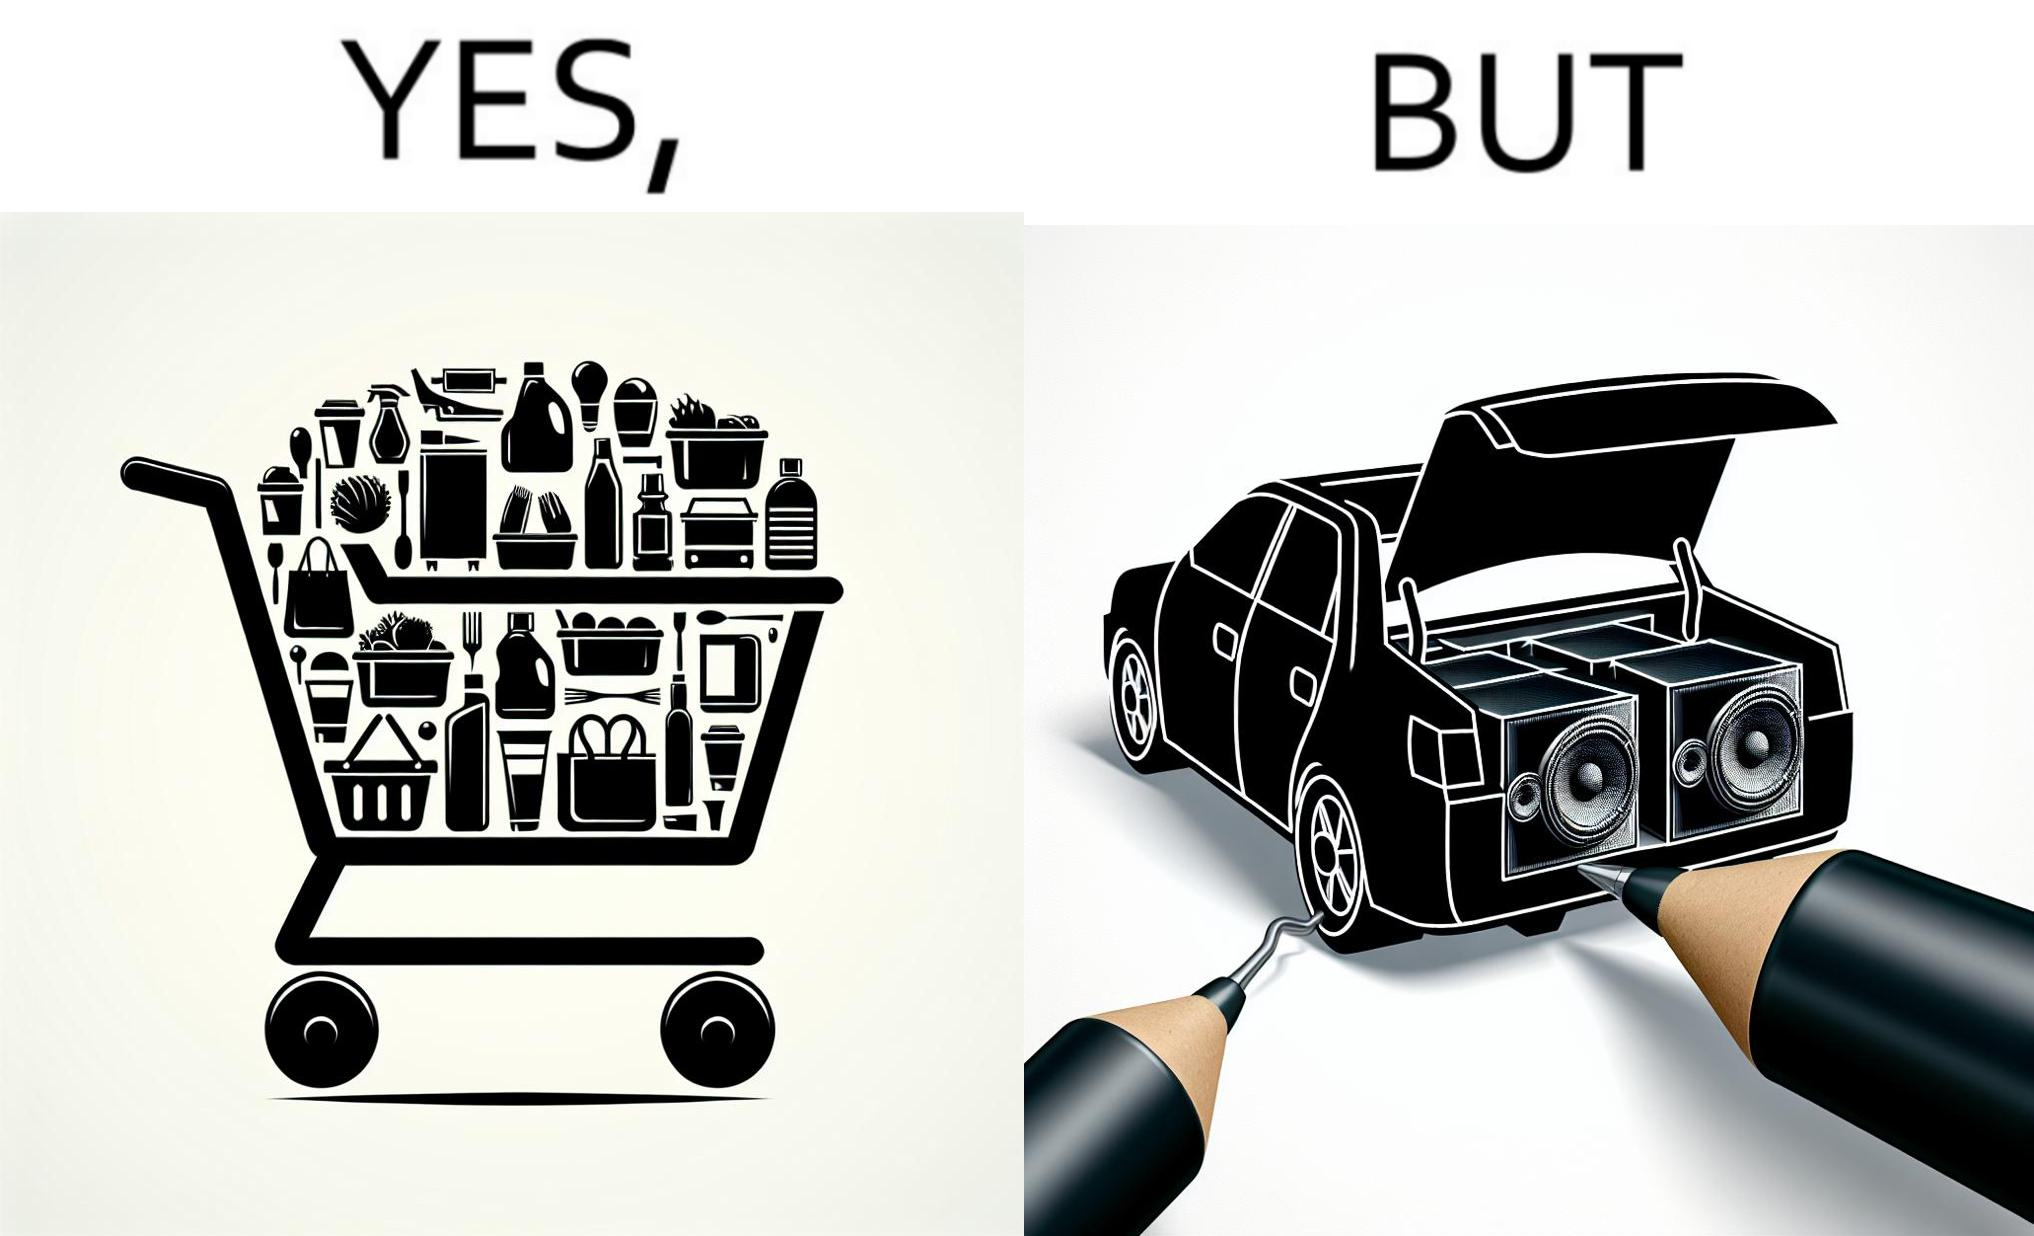Describe the satirical element in this image. The image is ironic, because a car trunk was earlier designed to keep some extra luggage or things but people nowadays get speakers installed in the trunk which in turn reduces the space in the trunk and making it difficult for people to store the extra luggage in the trunk 